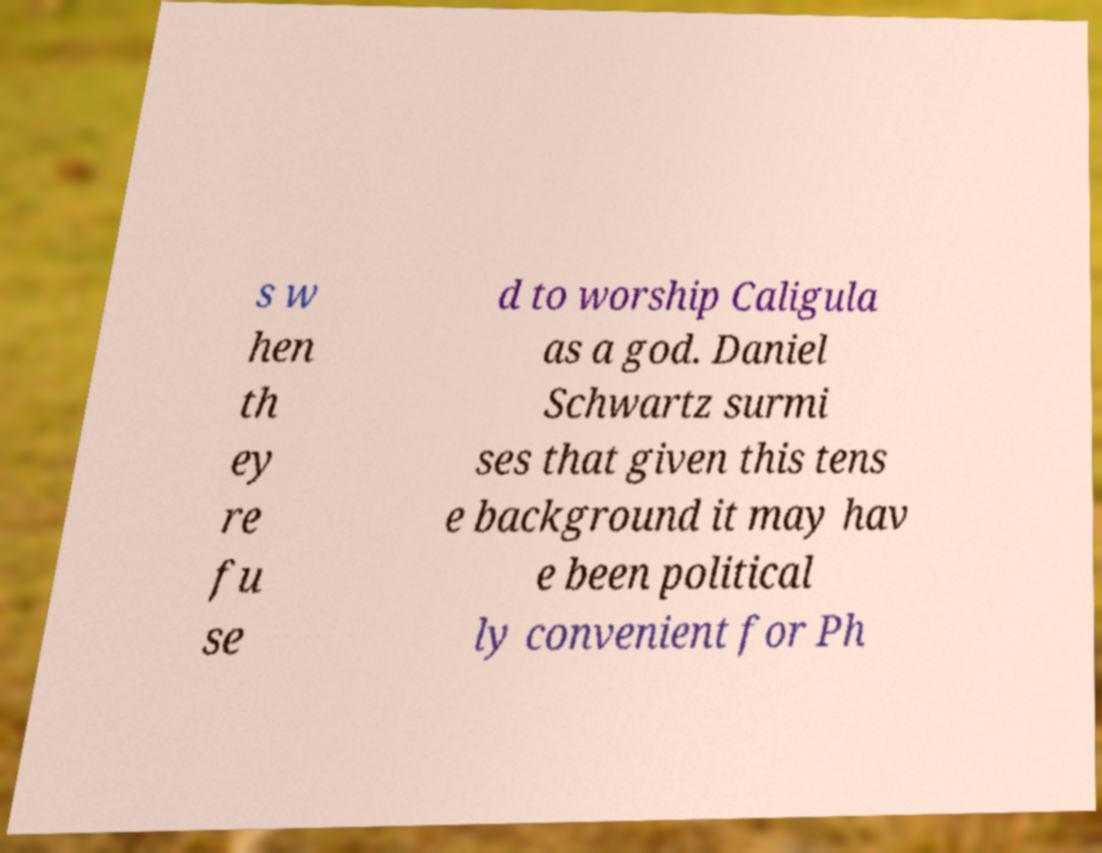Please identify and transcribe the text found in this image. s w hen th ey re fu se d to worship Caligula as a god. Daniel Schwartz surmi ses that given this tens e background it may hav e been political ly convenient for Ph 